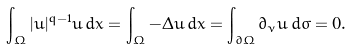<formula> <loc_0><loc_0><loc_500><loc_500>\int _ { \Omega } | u | ^ { q - 1 } u \, d x = \int _ { \Omega } - \Delta u \, d x = \int _ { \partial \Omega } \partial _ { \nu } u \, d \sigma = 0 .</formula> 